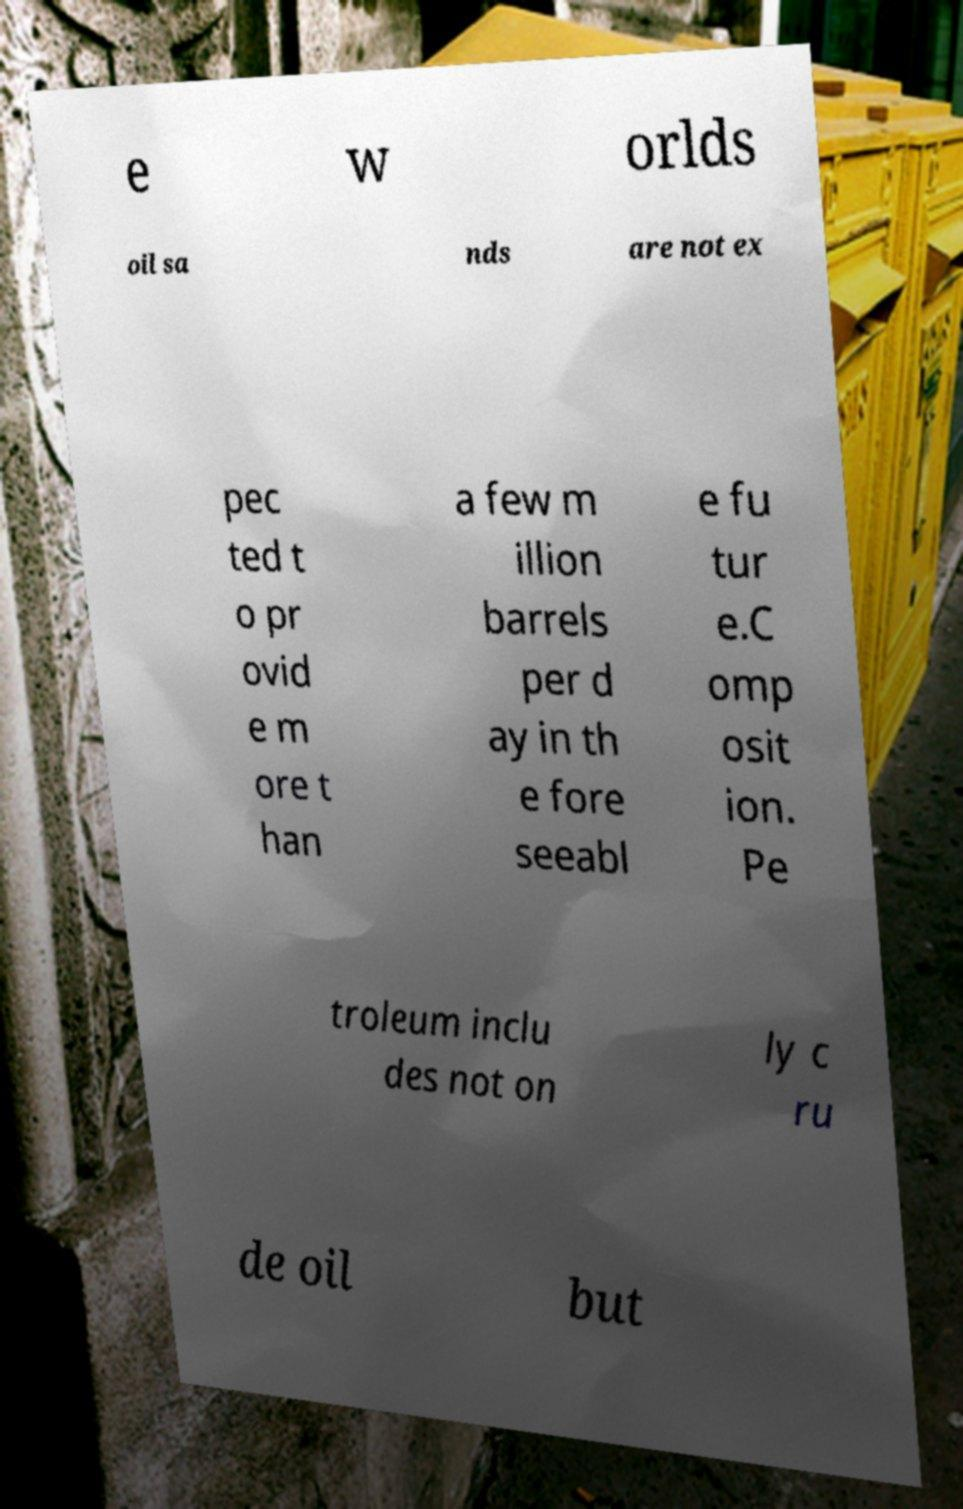Please identify and transcribe the text found in this image. e w orlds oil sa nds are not ex pec ted t o pr ovid e m ore t han a few m illion barrels per d ay in th e fore seeabl e fu tur e.C omp osit ion. Pe troleum inclu des not on ly c ru de oil but 